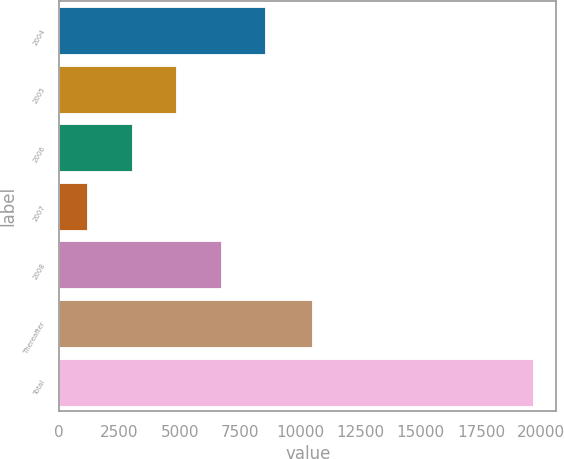<chart> <loc_0><loc_0><loc_500><loc_500><bar_chart><fcel>2004<fcel>2005<fcel>2006<fcel>2007<fcel>2008<fcel>Thereafter<fcel>Total<nl><fcel>8552.4<fcel>4857.2<fcel>3009.6<fcel>1162<fcel>6704.8<fcel>10483<fcel>19638<nl></chart> 